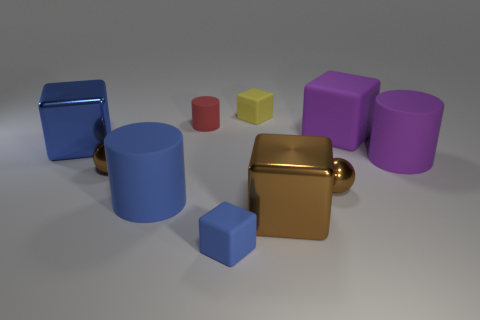Subtract all small cubes. How many cubes are left? 3 Subtract all purple blocks. How many blocks are left? 4 Subtract all spheres. How many objects are left? 8 Subtract all green cylinders. How many gray spheres are left? 0 Add 7 yellow objects. How many yellow objects exist? 8 Subtract 1 purple cubes. How many objects are left? 9 Subtract 1 balls. How many balls are left? 1 Subtract all cyan blocks. Subtract all gray cylinders. How many blocks are left? 5 Subtract all tiny yellow rubber blocks. Subtract all purple blocks. How many objects are left? 8 Add 7 matte cylinders. How many matte cylinders are left? 10 